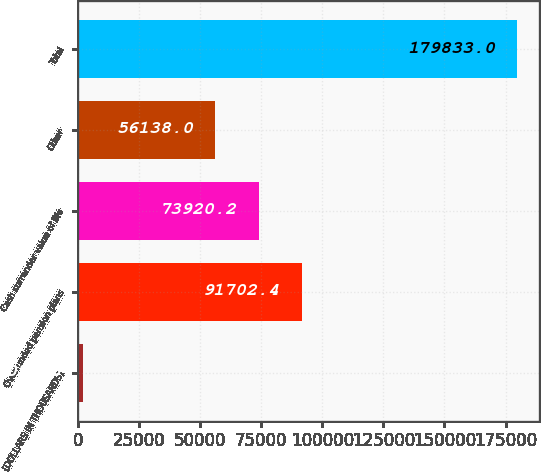Convert chart. <chart><loc_0><loc_0><loc_500><loc_500><bar_chart><fcel>(DOLLARS IN THOUSANDS)<fcel>Overfunded pension plans<fcel>Cash surrender value of life<fcel>Other<fcel>Total<nl><fcel>2011<fcel>91702.4<fcel>73920.2<fcel>56138<fcel>179833<nl></chart> 